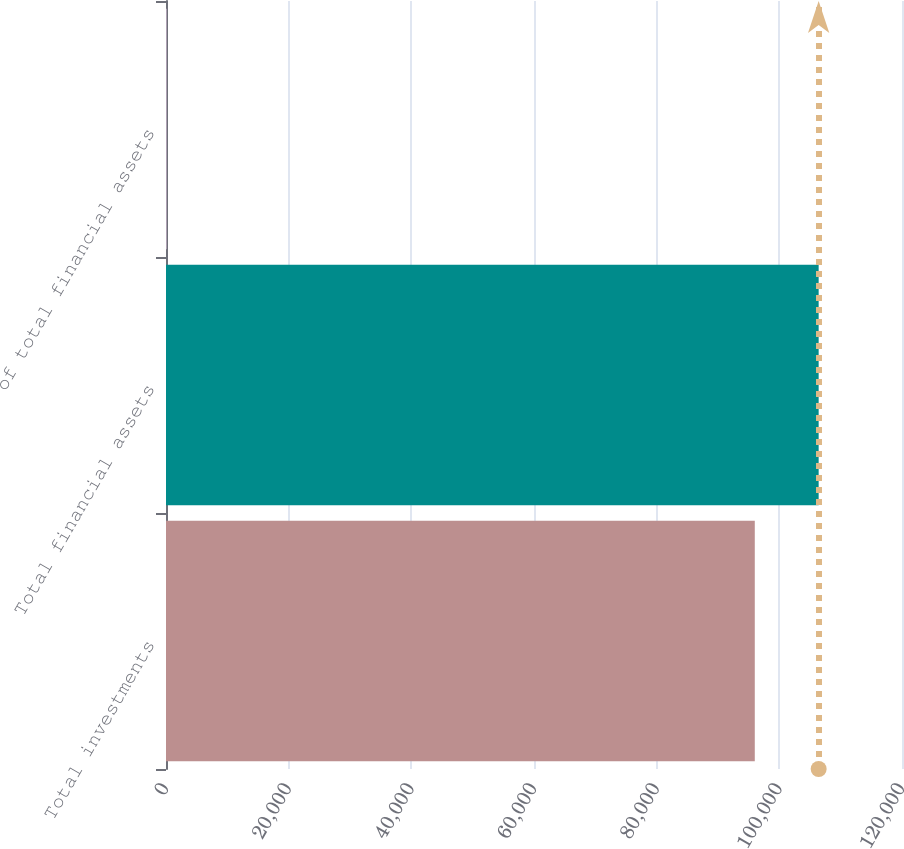Convert chart to OTSL. <chart><loc_0><loc_0><loc_500><loc_500><bar_chart><fcel>Total investments<fcel>Total financial assets<fcel>of total financial assets<nl><fcel>95998<fcel>106412<fcel>100<nl></chart> 